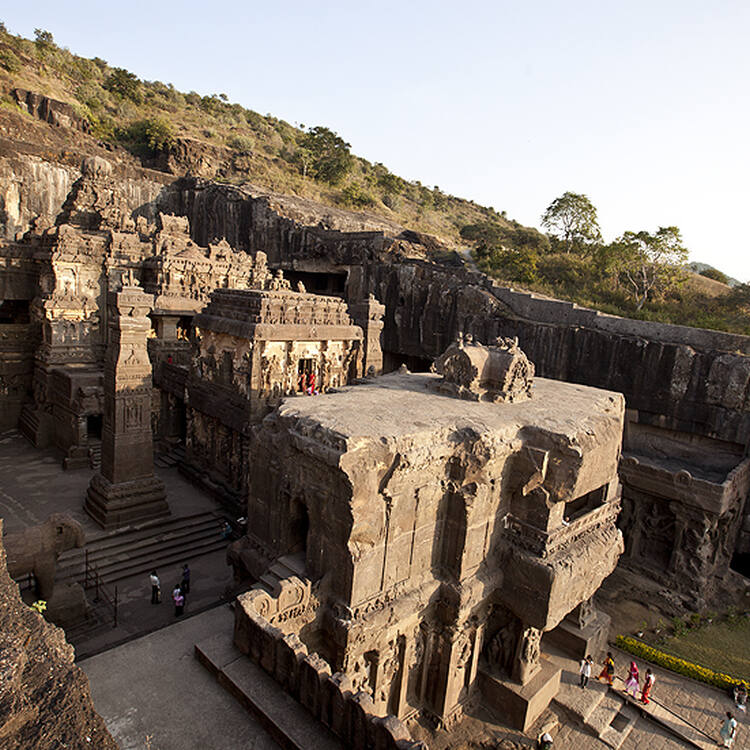If you could visit just one of the Ellora Caves, which one would you choose and why? If I could visit just one, I would choose Cave 16, also known as the Kailasa temple. This cave is the largest monolithic rock excavation in the world, meticulously carved from a single rock. Its architectural complexity, detailed carvings, and sheer scale make it a standout marvel in ellora. The intricate designs and the ingenuity involved in its creation are awe-inspiring, and the temple serves as a testament to human creativity and perseverance. 